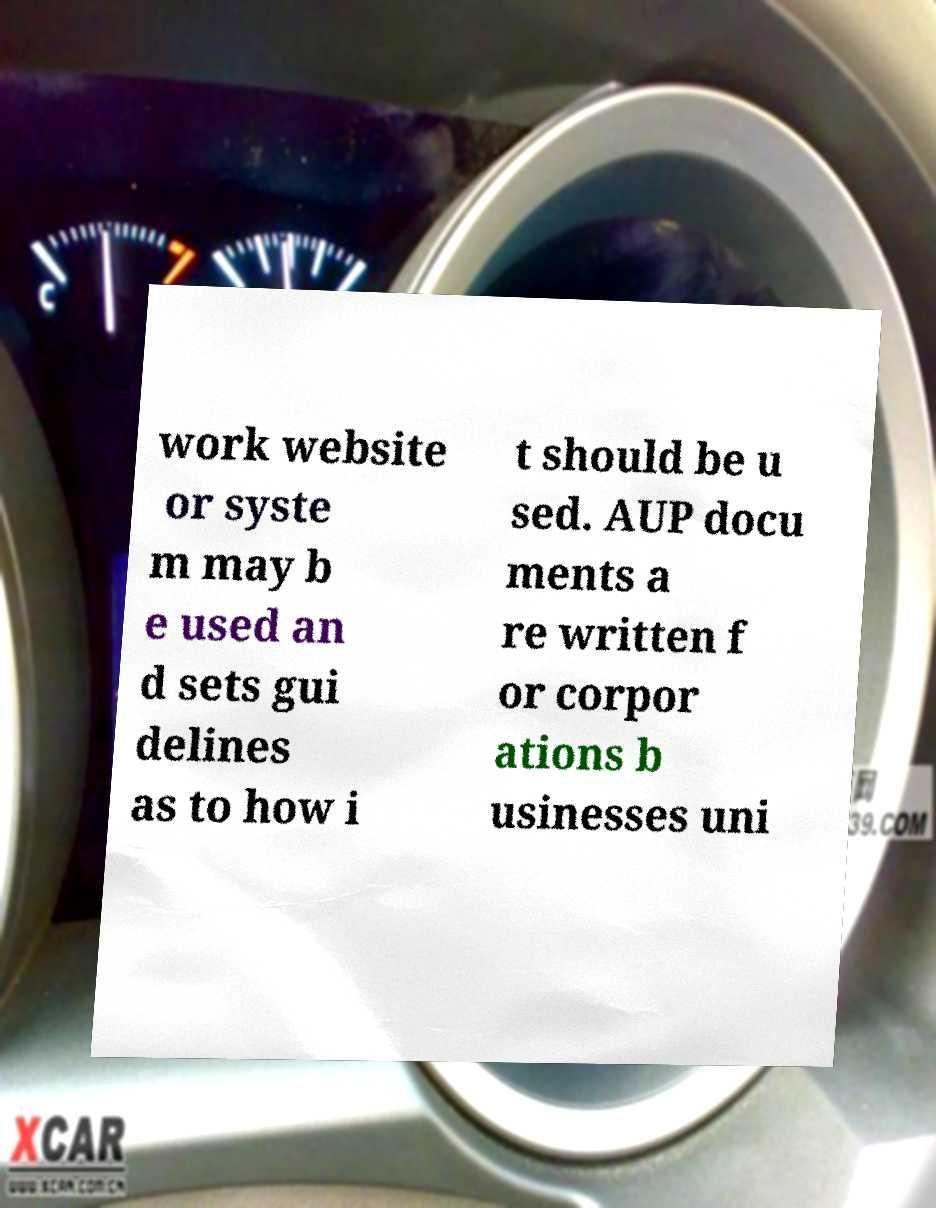Could you assist in decoding the text presented in this image and type it out clearly? work website or syste m may b e used an d sets gui delines as to how i t should be u sed. AUP docu ments a re written f or corpor ations b usinesses uni 